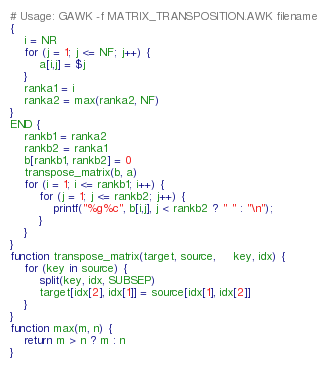<code> <loc_0><loc_0><loc_500><loc_500><_Awk_># Usage: GAWK -f MATRIX_TRANSPOSITION.AWK filename
{
    i = NR
    for (j = 1; j <= NF; j++) {
        a[i,j] = $j
    }
    ranka1 = i
    ranka2 = max(ranka2, NF)
}
END {
    rankb1 = ranka2
    rankb2 = ranka1
    b[rankb1, rankb2] = 0
    transpose_matrix(b, a)
    for (i = 1; i <= rankb1; i++) {
        for (j = 1; j <= rankb2; j++) {
            printf("%g%c", b[i,j], j < rankb2 ? " " : "\n");
        }
    }
}
function transpose_matrix(target, source,     key, idx) {
    for (key in source) {
        split(key, idx, SUBSEP)
        target[idx[2], idx[1]] = source[idx[1], idx[2]]
    }
}
function max(m, n) {
    return m > n ? m : n
}
</code> 